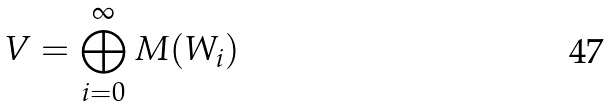Convert formula to latex. <formula><loc_0><loc_0><loc_500><loc_500>V = \bigoplus _ { i = 0 } ^ { \infty } M ( W _ { i } )</formula> 